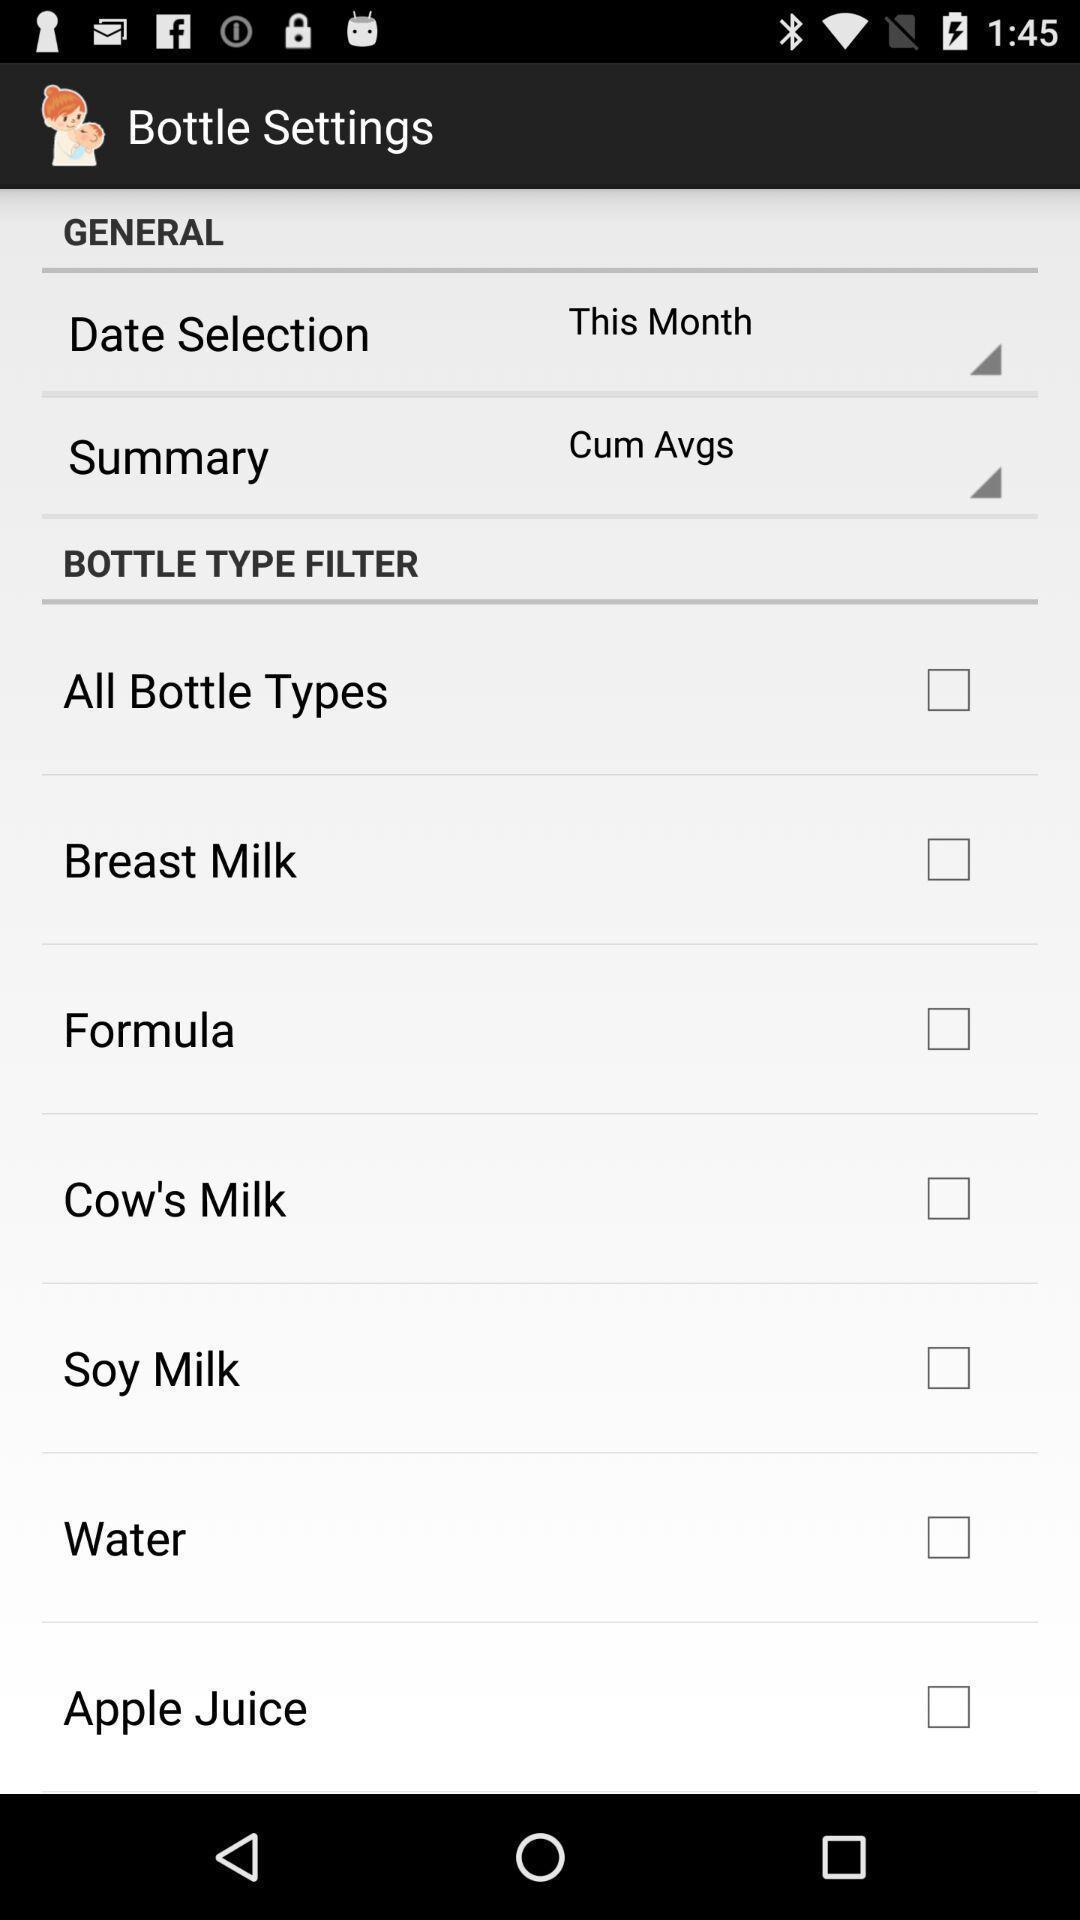Tell me about the visual elements in this screen capture. Page displaying general settings and different filter options. 